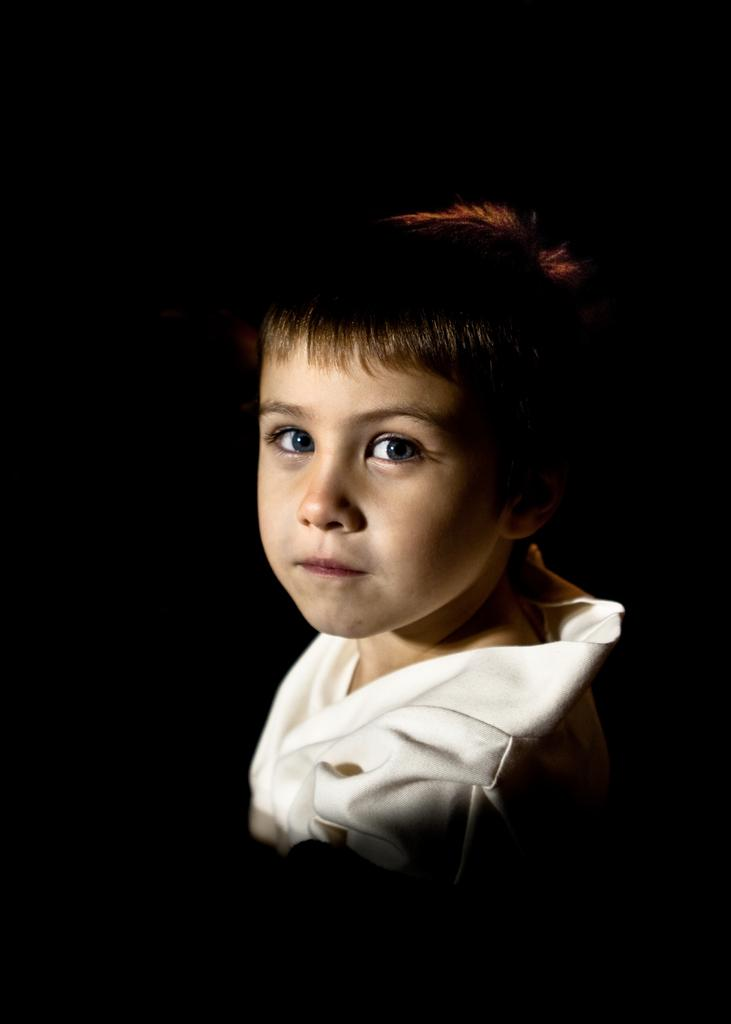What is the main subject of the image? There is a child in the center of the image. How many bones can be seen in the image? There are no bones visible in the image; it features a child in the center. 